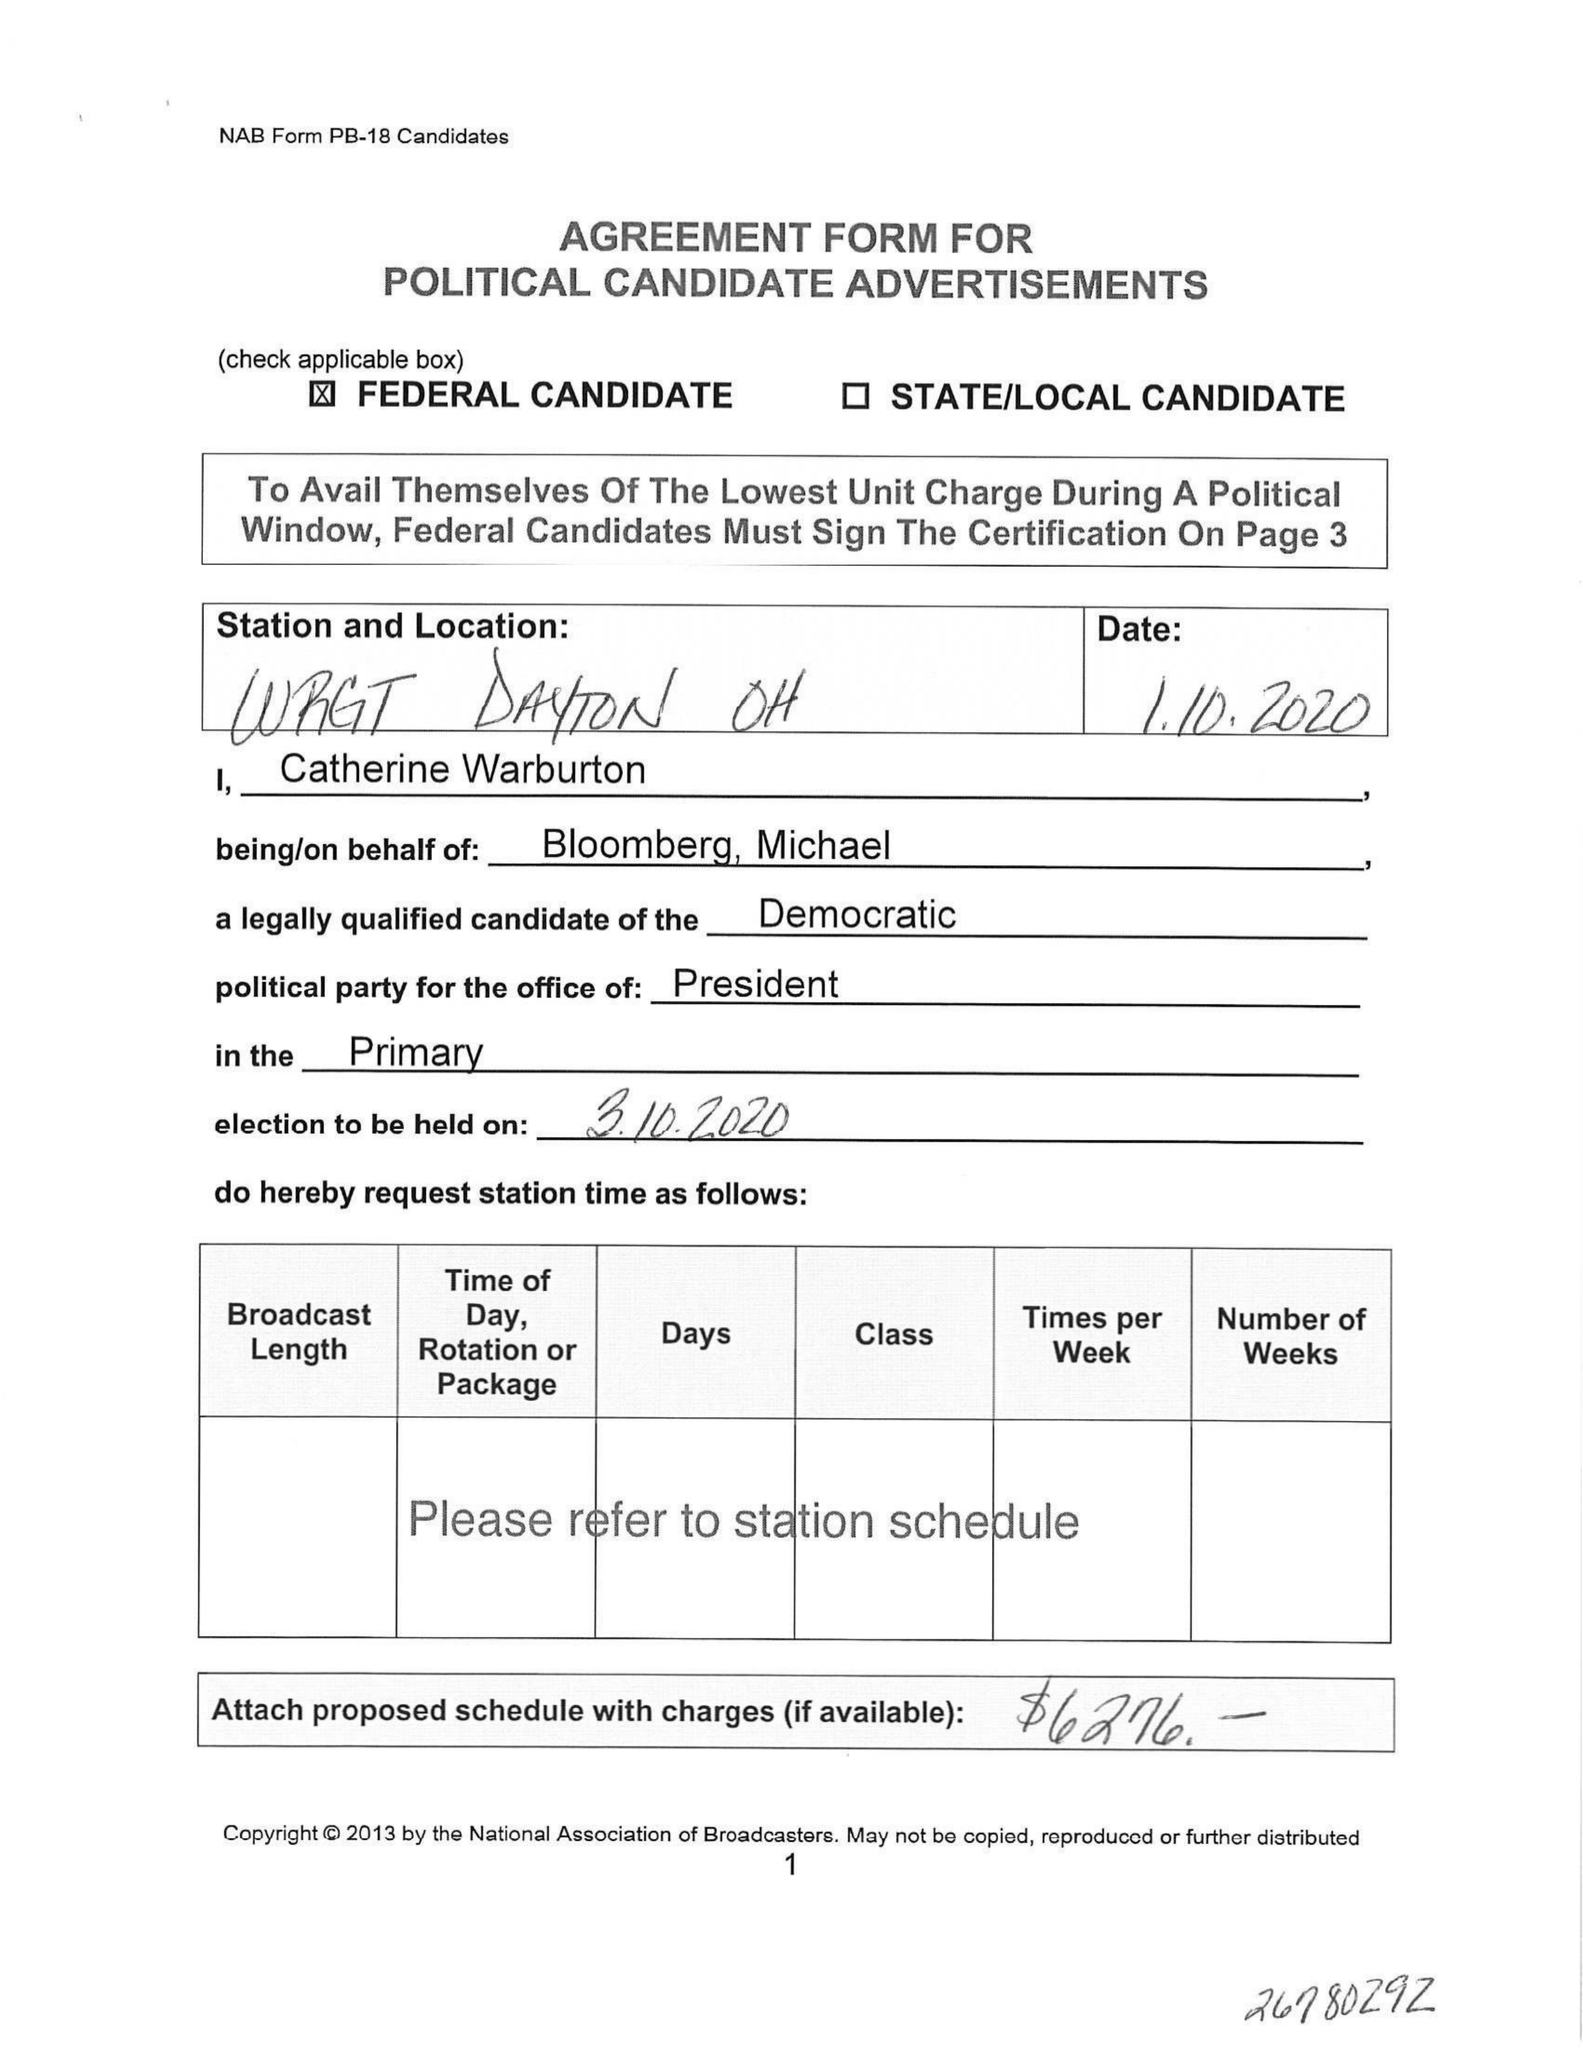What is the value for the gross_amount?
Answer the question using a single word or phrase. None 